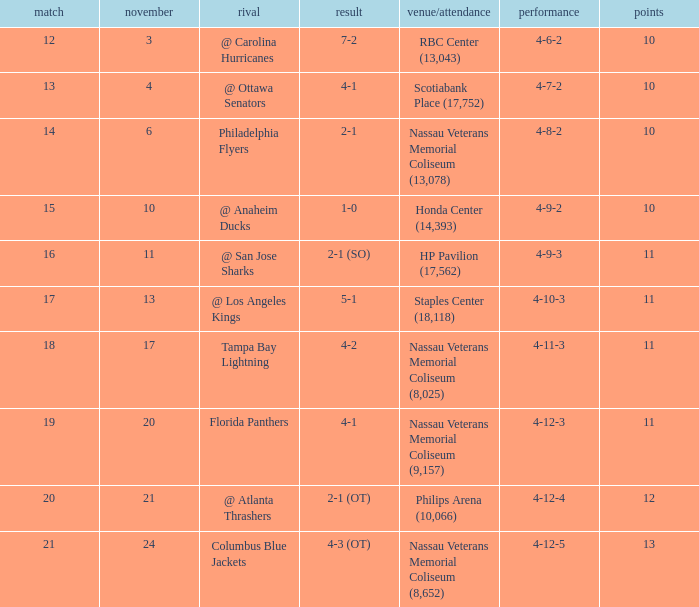What is the least amount of points? 10.0. 